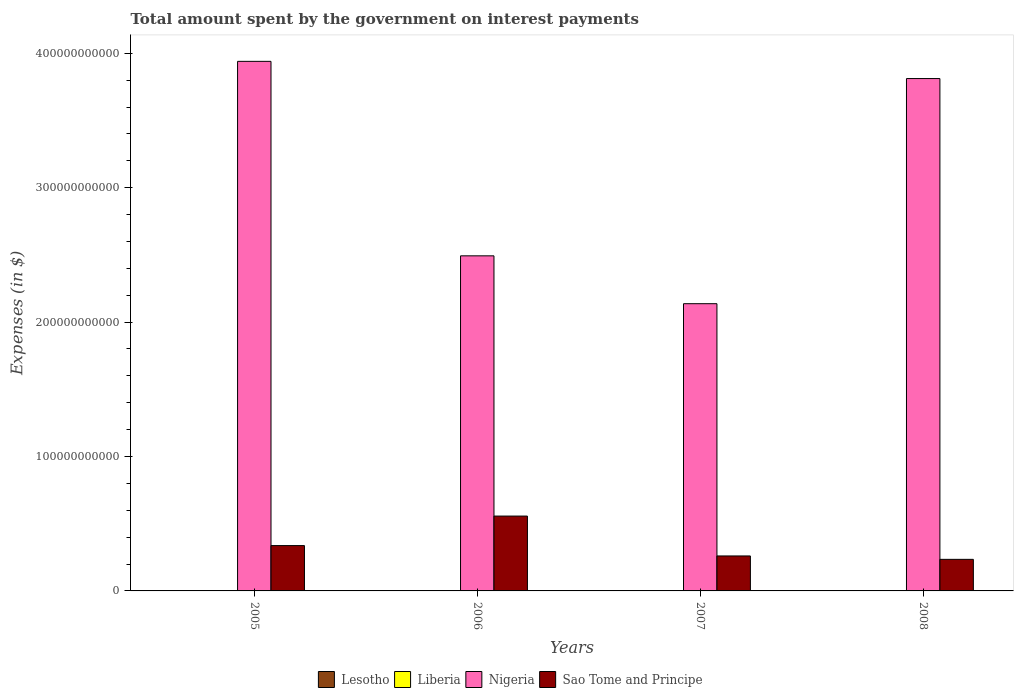Are the number of bars per tick equal to the number of legend labels?
Offer a terse response. Yes. How many bars are there on the 4th tick from the right?
Offer a terse response. 4. What is the label of the 4th group of bars from the left?
Make the answer very short. 2008. What is the amount spent on interest payments by the government in Lesotho in 2005?
Give a very brief answer. 2.25e+08. Across all years, what is the maximum amount spent on interest payments by the government in Liberia?
Provide a short and direct response. 7.01e+04. Across all years, what is the minimum amount spent on interest payments by the government in Lesotho?
Your answer should be very brief. 1.18e+08. In which year was the amount spent on interest payments by the government in Liberia maximum?
Provide a short and direct response. 2008. What is the total amount spent on interest payments by the government in Liberia in the graph?
Make the answer very short. 1.28e+05. What is the difference between the amount spent on interest payments by the government in Nigeria in 2005 and that in 2007?
Give a very brief answer. 1.80e+11. What is the difference between the amount spent on interest payments by the government in Sao Tome and Principe in 2008 and the amount spent on interest payments by the government in Liberia in 2005?
Ensure brevity in your answer.  2.35e+1. What is the average amount spent on interest payments by the government in Nigeria per year?
Make the answer very short. 3.10e+11. In the year 2008, what is the difference between the amount spent on interest payments by the government in Nigeria and amount spent on interest payments by the government in Sao Tome and Principe?
Offer a very short reply. 3.58e+11. In how many years, is the amount spent on interest payments by the government in Sao Tome and Principe greater than 120000000000 $?
Offer a very short reply. 0. What is the ratio of the amount spent on interest payments by the government in Sao Tome and Principe in 2005 to that in 2007?
Make the answer very short. 1.3. What is the difference between the highest and the second highest amount spent on interest payments by the government in Sao Tome and Principe?
Ensure brevity in your answer.  2.20e+1. What is the difference between the highest and the lowest amount spent on interest payments by the government in Sao Tome and Principe?
Your answer should be very brief. 3.22e+1. Is it the case that in every year, the sum of the amount spent on interest payments by the government in Sao Tome and Principe and amount spent on interest payments by the government in Nigeria is greater than the sum of amount spent on interest payments by the government in Liberia and amount spent on interest payments by the government in Lesotho?
Keep it short and to the point. Yes. What does the 3rd bar from the left in 2007 represents?
Offer a terse response. Nigeria. What does the 3rd bar from the right in 2006 represents?
Offer a very short reply. Liberia. Is it the case that in every year, the sum of the amount spent on interest payments by the government in Nigeria and amount spent on interest payments by the government in Sao Tome and Principe is greater than the amount spent on interest payments by the government in Lesotho?
Your response must be concise. Yes. Are all the bars in the graph horizontal?
Offer a very short reply. No. How many years are there in the graph?
Provide a succinct answer. 4. What is the difference between two consecutive major ticks on the Y-axis?
Ensure brevity in your answer.  1.00e+11. Does the graph contain any zero values?
Your response must be concise. No. What is the title of the graph?
Give a very brief answer. Total amount spent by the government on interest payments. What is the label or title of the X-axis?
Your answer should be compact. Years. What is the label or title of the Y-axis?
Your answer should be very brief. Expenses (in $). What is the Expenses (in $) of Lesotho in 2005?
Keep it short and to the point. 2.25e+08. What is the Expenses (in $) of Liberia in 2005?
Keep it short and to the point. 1.48e+04. What is the Expenses (in $) of Nigeria in 2005?
Make the answer very short. 3.94e+11. What is the Expenses (in $) in Sao Tome and Principe in 2005?
Keep it short and to the point. 3.37e+1. What is the Expenses (in $) in Lesotho in 2006?
Your answer should be very brief. 3.08e+08. What is the Expenses (in $) in Liberia in 2006?
Offer a very short reply. 2.07e+04. What is the Expenses (in $) of Nigeria in 2006?
Give a very brief answer. 2.49e+11. What is the Expenses (in $) in Sao Tome and Principe in 2006?
Provide a succinct answer. 5.57e+1. What is the Expenses (in $) in Lesotho in 2007?
Make the answer very short. 2.93e+08. What is the Expenses (in $) in Liberia in 2007?
Offer a terse response. 2.20e+04. What is the Expenses (in $) in Nigeria in 2007?
Provide a short and direct response. 2.14e+11. What is the Expenses (in $) in Sao Tome and Principe in 2007?
Offer a terse response. 2.60e+1. What is the Expenses (in $) of Lesotho in 2008?
Your answer should be very brief. 1.18e+08. What is the Expenses (in $) in Liberia in 2008?
Make the answer very short. 7.01e+04. What is the Expenses (in $) of Nigeria in 2008?
Keep it short and to the point. 3.81e+11. What is the Expenses (in $) of Sao Tome and Principe in 2008?
Offer a very short reply. 2.35e+1. Across all years, what is the maximum Expenses (in $) in Lesotho?
Your answer should be very brief. 3.08e+08. Across all years, what is the maximum Expenses (in $) of Liberia?
Keep it short and to the point. 7.01e+04. Across all years, what is the maximum Expenses (in $) of Nigeria?
Provide a short and direct response. 3.94e+11. Across all years, what is the maximum Expenses (in $) of Sao Tome and Principe?
Keep it short and to the point. 5.57e+1. Across all years, what is the minimum Expenses (in $) of Lesotho?
Offer a very short reply. 1.18e+08. Across all years, what is the minimum Expenses (in $) of Liberia?
Make the answer very short. 1.48e+04. Across all years, what is the minimum Expenses (in $) of Nigeria?
Your answer should be compact. 2.14e+11. Across all years, what is the minimum Expenses (in $) of Sao Tome and Principe?
Offer a very short reply. 2.35e+1. What is the total Expenses (in $) of Lesotho in the graph?
Your answer should be compact. 9.44e+08. What is the total Expenses (in $) of Liberia in the graph?
Ensure brevity in your answer.  1.28e+05. What is the total Expenses (in $) of Nigeria in the graph?
Your answer should be compact. 1.24e+12. What is the total Expenses (in $) in Sao Tome and Principe in the graph?
Ensure brevity in your answer.  1.39e+11. What is the difference between the Expenses (in $) in Lesotho in 2005 and that in 2006?
Your response must be concise. -8.32e+07. What is the difference between the Expenses (in $) of Liberia in 2005 and that in 2006?
Give a very brief answer. -5850.55. What is the difference between the Expenses (in $) of Nigeria in 2005 and that in 2006?
Provide a short and direct response. 1.45e+11. What is the difference between the Expenses (in $) in Sao Tome and Principe in 2005 and that in 2006?
Make the answer very short. -2.20e+1. What is the difference between the Expenses (in $) of Lesotho in 2005 and that in 2007?
Provide a succinct answer. -6.74e+07. What is the difference between the Expenses (in $) in Liberia in 2005 and that in 2007?
Ensure brevity in your answer.  -7224.07. What is the difference between the Expenses (in $) of Nigeria in 2005 and that in 2007?
Ensure brevity in your answer.  1.80e+11. What is the difference between the Expenses (in $) in Sao Tome and Principe in 2005 and that in 2007?
Offer a very short reply. 7.71e+09. What is the difference between the Expenses (in $) in Lesotho in 2005 and that in 2008?
Provide a short and direct response. 1.07e+08. What is the difference between the Expenses (in $) in Liberia in 2005 and that in 2008?
Your answer should be compact. -5.53e+04. What is the difference between the Expenses (in $) of Nigeria in 2005 and that in 2008?
Your answer should be compact. 1.28e+1. What is the difference between the Expenses (in $) in Sao Tome and Principe in 2005 and that in 2008?
Your answer should be very brief. 1.02e+1. What is the difference between the Expenses (in $) in Lesotho in 2006 and that in 2007?
Ensure brevity in your answer.  1.58e+07. What is the difference between the Expenses (in $) in Liberia in 2006 and that in 2007?
Your answer should be compact. -1373.52. What is the difference between the Expenses (in $) in Nigeria in 2006 and that in 2007?
Make the answer very short. 3.56e+1. What is the difference between the Expenses (in $) of Sao Tome and Principe in 2006 and that in 2007?
Your response must be concise. 2.97e+1. What is the difference between the Expenses (in $) in Lesotho in 2006 and that in 2008?
Your answer should be very brief. 1.90e+08. What is the difference between the Expenses (in $) of Liberia in 2006 and that in 2008?
Offer a terse response. -4.94e+04. What is the difference between the Expenses (in $) of Nigeria in 2006 and that in 2008?
Make the answer very short. -1.32e+11. What is the difference between the Expenses (in $) of Sao Tome and Principe in 2006 and that in 2008?
Make the answer very short. 3.22e+1. What is the difference between the Expenses (in $) in Lesotho in 2007 and that in 2008?
Give a very brief answer. 1.74e+08. What is the difference between the Expenses (in $) in Liberia in 2007 and that in 2008?
Your answer should be very brief. -4.80e+04. What is the difference between the Expenses (in $) of Nigeria in 2007 and that in 2008?
Offer a very short reply. -1.68e+11. What is the difference between the Expenses (in $) of Sao Tome and Principe in 2007 and that in 2008?
Make the answer very short. 2.54e+09. What is the difference between the Expenses (in $) of Lesotho in 2005 and the Expenses (in $) of Liberia in 2006?
Offer a terse response. 2.25e+08. What is the difference between the Expenses (in $) of Lesotho in 2005 and the Expenses (in $) of Nigeria in 2006?
Your answer should be very brief. -2.49e+11. What is the difference between the Expenses (in $) of Lesotho in 2005 and the Expenses (in $) of Sao Tome and Principe in 2006?
Make the answer very short. -5.55e+1. What is the difference between the Expenses (in $) of Liberia in 2005 and the Expenses (in $) of Nigeria in 2006?
Your answer should be compact. -2.49e+11. What is the difference between the Expenses (in $) of Liberia in 2005 and the Expenses (in $) of Sao Tome and Principe in 2006?
Provide a succinct answer. -5.57e+1. What is the difference between the Expenses (in $) in Nigeria in 2005 and the Expenses (in $) in Sao Tome and Principe in 2006?
Keep it short and to the point. 3.38e+11. What is the difference between the Expenses (in $) of Lesotho in 2005 and the Expenses (in $) of Liberia in 2007?
Ensure brevity in your answer.  2.25e+08. What is the difference between the Expenses (in $) in Lesotho in 2005 and the Expenses (in $) in Nigeria in 2007?
Your answer should be very brief. -2.13e+11. What is the difference between the Expenses (in $) of Lesotho in 2005 and the Expenses (in $) of Sao Tome and Principe in 2007?
Give a very brief answer. -2.58e+1. What is the difference between the Expenses (in $) of Liberia in 2005 and the Expenses (in $) of Nigeria in 2007?
Keep it short and to the point. -2.14e+11. What is the difference between the Expenses (in $) of Liberia in 2005 and the Expenses (in $) of Sao Tome and Principe in 2007?
Make the answer very short. -2.60e+1. What is the difference between the Expenses (in $) in Nigeria in 2005 and the Expenses (in $) in Sao Tome and Principe in 2007?
Ensure brevity in your answer.  3.68e+11. What is the difference between the Expenses (in $) in Lesotho in 2005 and the Expenses (in $) in Liberia in 2008?
Your answer should be very brief. 2.25e+08. What is the difference between the Expenses (in $) in Lesotho in 2005 and the Expenses (in $) in Nigeria in 2008?
Your answer should be compact. -3.81e+11. What is the difference between the Expenses (in $) in Lesotho in 2005 and the Expenses (in $) in Sao Tome and Principe in 2008?
Offer a terse response. -2.33e+1. What is the difference between the Expenses (in $) of Liberia in 2005 and the Expenses (in $) of Nigeria in 2008?
Your answer should be very brief. -3.81e+11. What is the difference between the Expenses (in $) in Liberia in 2005 and the Expenses (in $) in Sao Tome and Principe in 2008?
Your response must be concise. -2.35e+1. What is the difference between the Expenses (in $) of Nigeria in 2005 and the Expenses (in $) of Sao Tome and Principe in 2008?
Make the answer very short. 3.71e+11. What is the difference between the Expenses (in $) of Lesotho in 2006 and the Expenses (in $) of Liberia in 2007?
Your response must be concise. 3.08e+08. What is the difference between the Expenses (in $) in Lesotho in 2006 and the Expenses (in $) in Nigeria in 2007?
Keep it short and to the point. -2.13e+11. What is the difference between the Expenses (in $) in Lesotho in 2006 and the Expenses (in $) in Sao Tome and Principe in 2007?
Give a very brief answer. -2.57e+1. What is the difference between the Expenses (in $) of Liberia in 2006 and the Expenses (in $) of Nigeria in 2007?
Offer a very short reply. -2.14e+11. What is the difference between the Expenses (in $) in Liberia in 2006 and the Expenses (in $) in Sao Tome and Principe in 2007?
Keep it short and to the point. -2.60e+1. What is the difference between the Expenses (in $) of Nigeria in 2006 and the Expenses (in $) of Sao Tome and Principe in 2007?
Offer a terse response. 2.23e+11. What is the difference between the Expenses (in $) in Lesotho in 2006 and the Expenses (in $) in Liberia in 2008?
Ensure brevity in your answer.  3.08e+08. What is the difference between the Expenses (in $) of Lesotho in 2006 and the Expenses (in $) of Nigeria in 2008?
Ensure brevity in your answer.  -3.81e+11. What is the difference between the Expenses (in $) of Lesotho in 2006 and the Expenses (in $) of Sao Tome and Principe in 2008?
Ensure brevity in your answer.  -2.32e+1. What is the difference between the Expenses (in $) in Liberia in 2006 and the Expenses (in $) in Nigeria in 2008?
Keep it short and to the point. -3.81e+11. What is the difference between the Expenses (in $) in Liberia in 2006 and the Expenses (in $) in Sao Tome and Principe in 2008?
Ensure brevity in your answer.  -2.35e+1. What is the difference between the Expenses (in $) of Nigeria in 2006 and the Expenses (in $) of Sao Tome and Principe in 2008?
Your answer should be compact. 2.26e+11. What is the difference between the Expenses (in $) in Lesotho in 2007 and the Expenses (in $) in Liberia in 2008?
Your response must be concise. 2.92e+08. What is the difference between the Expenses (in $) of Lesotho in 2007 and the Expenses (in $) of Nigeria in 2008?
Ensure brevity in your answer.  -3.81e+11. What is the difference between the Expenses (in $) of Lesotho in 2007 and the Expenses (in $) of Sao Tome and Principe in 2008?
Keep it short and to the point. -2.32e+1. What is the difference between the Expenses (in $) in Liberia in 2007 and the Expenses (in $) in Nigeria in 2008?
Your response must be concise. -3.81e+11. What is the difference between the Expenses (in $) in Liberia in 2007 and the Expenses (in $) in Sao Tome and Principe in 2008?
Ensure brevity in your answer.  -2.35e+1. What is the difference between the Expenses (in $) in Nigeria in 2007 and the Expenses (in $) in Sao Tome and Principe in 2008?
Provide a succinct answer. 1.90e+11. What is the average Expenses (in $) of Lesotho per year?
Keep it short and to the point. 2.36e+08. What is the average Expenses (in $) in Liberia per year?
Your answer should be compact. 3.19e+04. What is the average Expenses (in $) in Nigeria per year?
Provide a succinct answer. 3.10e+11. What is the average Expenses (in $) in Sao Tome and Principe per year?
Make the answer very short. 3.47e+1. In the year 2005, what is the difference between the Expenses (in $) in Lesotho and Expenses (in $) in Liberia?
Keep it short and to the point. 2.25e+08. In the year 2005, what is the difference between the Expenses (in $) of Lesotho and Expenses (in $) of Nigeria?
Offer a terse response. -3.94e+11. In the year 2005, what is the difference between the Expenses (in $) in Lesotho and Expenses (in $) in Sao Tome and Principe?
Your answer should be compact. -3.35e+1. In the year 2005, what is the difference between the Expenses (in $) in Liberia and Expenses (in $) in Nigeria?
Give a very brief answer. -3.94e+11. In the year 2005, what is the difference between the Expenses (in $) in Liberia and Expenses (in $) in Sao Tome and Principe?
Provide a succinct answer. -3.37e+1. In the year 2005, what is the difference between the Expenses (in $) in Nigeria and Expenses (in $) in Sao Tome and Principe?
Make the answer very short. 3.60e+11. In the year 2006, what is the difference between the Expenses (in $) of Lesotho and Expenses (in $) of Liberia?
Your answer should be very brief. 3.08e+08. In the year 2006, what is the difference between the Expenses (in $) in Lesotho and Expenses (in $) in Nigeria?
Give a very brief answer. -2.49e+11. In the year 2006, what is the difference between the Expenses (in $) of Lesotho and Expenses (in $) of Sao Tome and Principe?
Keep it short and to the point. -5.54e+1. In the year 2006, what is the difference between the Expenses (in $) of Liberia and Expenses (in $) of Nigeria?
Ensure brevity in your answer.  -2.49e+11. In the year 2006, what is the difference between the Expenses (in $) of Liberia and Expenses (in $) of Sao Tome and Principe?
Your answer should be very brief. -5.57e+1. In the year 2006, what is the difference between the Expenses (in $) of Nigeria and Expenses (in $) of Sao Tome and Principe?
Give a very brief answer. 1.94e+11. In the year 2007, what is the difference between the Expenses (in $) of Lesotho and Expenses (in $) of Liberia?
Provide a succinct answer. 2.93e+08. In the year 2007, what is the difference between the Expenses (in $) in Lesotho and Expenses (in $) in Nigeria?
Make the answer very short. -2.13e+11. In the year 2007, what is the difference between the Expenses (in $) in Lesotho and Expenses (in $) in Sao Tome and Principe?
Offer a very short reply. -2.57e+1. In the year 2007, what is the difference between the Expenses (in $) in Liberia and Expenses (in $) in Nigeria?
Give a very brief answer. -2.14e+11. In the year 2007, what is the difference between the Expenses (in $) in Liberia and Expenses (in $) in Sao Tome and Principe?
Provide a succinct answer. -2.60e+1. In the year 2007, what is the difference between the Expenses (in $) in Nigeria and Expenses (in $) in Sao Tome and Principe?
Make the answer very short. 1.88e+11. In the year 2008, what is the difference between the Expenses (in $) of Lesotho and Expenses (in $) of Liberia?
Your answer should be very brief. 1.18e+08. In the year 2008, what is the difference between the Expenses (in $) in Lesotho and Expenses (in $) in Nigeria?
Offer a very short reply. -3.81e+11. In the year 2008, what is the difference between the Expenses (in $) in Lesotho and Expenses (in $) in Sao Tome and Principe?
Offer a terse response. -2.34e+1. In the year 2008, what is the difference between the Expenses (in $) in Liberia and Expenses (in $) in Nigeria?
Keep it short and to the point. -3.81e+11. In the year 2008, what is the difference between the Expenses (in $) of Liberia and Expenses (in $) of Sao Tome and Principe?
Provide a succinct answer. -2.35e+1. In the year 2008, what is the difference between the Expenses (in $) in Nigeria and Expenses (in $) in Sao Tome and Principe?
Provide a short and direct response. 3.58e+11. What is the ratio of the Expenses (in $) of Lesotho in 2005 to that in 2006?
Ensure brevity in your answer.  0.73. What is the ratio of the Expenses (in $) in Liberia in 2005 to that in 2006?
Make the answer very short. 0.72. What is the ratio of the Expenses (in $) of Nigeria in 2005 to that in 2006?
Your answer should be compact. 1.58. What is the ratio of the Expenses (in $) in Sao Tome and Principe in 2005 to that in 2006?
Offer a very short reply. 0.61. What is the ratio of the Expenses (in $) of Lesotho in 2005 to that in 2007?
Provide a succinct answer. 0.77. What is the ratio of the Expenses (in $) of Liberia in 2005 to that in 2007?
Make the answer very short. 0.67. What is the ratio of the Expenses (in $) of Nigeria in 2005 to that in 2007?
Provide a short and direct response. 1.84. What is the ratio of the Expenses (in $) in Sao Tome and Principe in 2005 to that in 2007?
Provide a succinct answer. 1.3. What is the ratio of the Expenses (in $) of Lesotho in 2005 to that in 2008?
Make the answer very short. 1.9. What is the ratio of the Expenses (in $) of Liberia in 2005 to that in 2008?
Offer a terse response. 0.21. What is the ratio of the Expenses (in $) of Nigeria in 2005 to that in 2008?
Provide a short and direct response. 1.03. What is the ratio of the Expenses (in $) of Sao Tome and Principe in 2005 to that in 2008?
Provide a short and direct response. 1.44. What is the ratio of the Expenses (in $) of Lesotho in 2006 to that in 2007?
Your answer should be compact. 1.05. What is the ratio of the Expenses (in $) of Liberia in 2006 to that in 2007?
Keep it short and to the point. 0.94. What is the ratio of the Expenses (in $) in Nigeria in 2006 to that in 2007?
Keep it short and to the point. 1.17. What is the ratio of the Expenses (in $) in Sao Tome and Principe in 2006 to that in 2007?
Offer a terse response. 2.14. What is the ratio of the Expenses (in $) in Lesotho in 2006 to that in 2008?
Give a very brief answer. 2.6. What is the ratio of the Expenses (in $) in Liberia in 2006 to that in 2008?
Provide a succinct answer. 0.29. What is the ratio of the Expenses (in $) of Nigeria in 2006 to that in 2008?
Provide a short and direct response. 0.65. What is the ratio of the Expenses (in $) of Sao Tome and Principe in 2006 to that in 2008?
Your answer should be very brief. 2.37. What is the ratio of the Expenses (in $) of Lesotho in 2007 to that in 2008?
Offer a very short reply. 2.47. What is the ratio of the Expenses (in $) of Liberia in 2007 to that in 2008?
Offer a very short reply. 0.31. What is the ratio of the Expenses (in $) in Nigeria in 2007 to that in 2008?
Offer a terse response. 0.56. What is the ratio of the Expenses (in $) in Sao Tome and Principe in 2007 to that in 2008?
Ensure brevity in your answer.  1.11. What is the difference between the highest and the second highest Expenses (in $) in Lesotho?
Your response must be concise. 1.58e+07. What is the difference between the highest and the second highest Expenses (in $) in Liberia?
Make the answer very short. 4.80e+04. What is the difference between the highest and the second highest Expenses (in $) in Nigeria?
Keep it short and to the point. 1.28e+1. What is the difference between the highest and the second highest Expenses (in $) in Sao Tome and Principe?
Keep it short and to the point. 2.20e+1. What is the difference between the highest and the lowest Expenses (in $) in Lesotho?
Offer a very short reply. 1.90e+08. What is the difference between the highest and the lowest Expenses (in $) in Liberia?
Offer a very short reply. 5.53e+04. What is the difference between the highest and the lowest Expenses (in $) in Nigeria?
Offer a terse response. 1.80e+11. What is the difference between the highest and the lowest Expenses (in $) of Sao Tome and Principe?
Provide a short and direct response. 3.22e+1. 